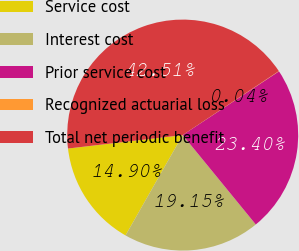Convert chart. <chart><loc_0><loc_0><loc_500><loc_500><pie_chart><fcel>Service cost<fcel>Interest cost<fcel>Prior service cost<fcel>Recognized actuarial loss<fcel>Total net periodic benefit<nl><fcel>14.9%<fcel>19.15%<fcel>23.4%<fcel>0.04%<fcel>42.51%<nl></chart> 